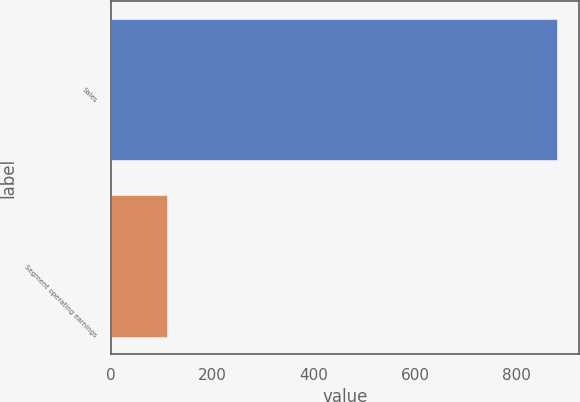Convert chart to OTSL. <chart><loc_0><loc_0><loc_500><loc_500><bar_chart><fcel>Sales<fcel>Segment operating earnings<nl><fcel>879.6<fcel>110.3<nl></chart> 